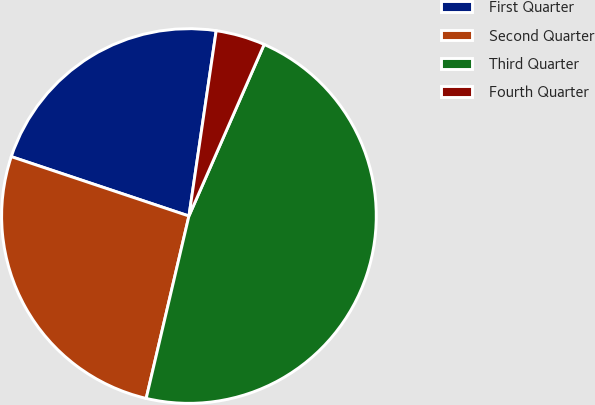Convert chart to OTSL. <chart><loc_0><loc_0><loc_500><loc_500><pie_chart><fcel>First Quarter<fcel>Second Quarter<fcel>Third Quarter<fcel>Fourth Quarter<nl><fcel>22.19%<fcel>26.47%<fcel>47.09%<fcel>4.25%<nl></chart> 